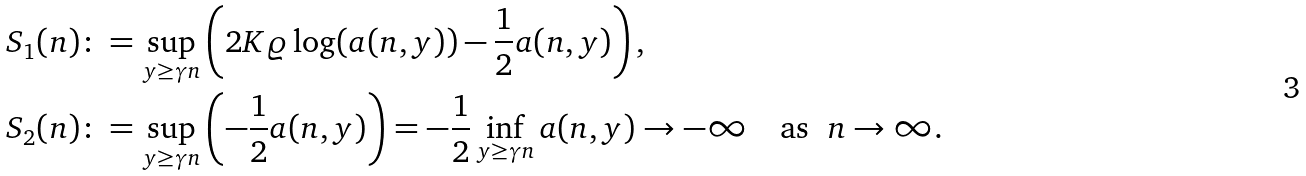<formula> <loc_0><loc_0><loc_500><loc_500>S _ { 1 } ( n ) & \colon = \sup _ { y \geq \gamma n } \left ( 2 K \varrho \log ( a ( n , y ) ) - \frac { 1 } { 2 } a ( n , y ) \right ) , \\ S _ { 2 } ( n ) & \colon = \sup _ { y \geq \gamma n } \left ( - \frac { 1 } { 2 } a ( n , y ) \right ) = - \frac { 1 } { 2 } \inf _ { y \geq \gamma n } a ( n , y ) \to - \infty \quad \text {as \ $n \to \infty$.}</formula> 